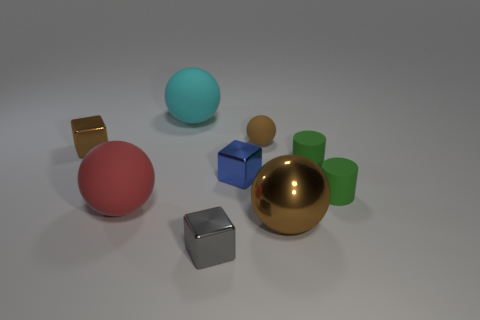What number of other things are the same shape as the small brown rubber thing?
Your answer should be very brief. 3. Is the gray cube the same size as the cyan rubber ball?
Keep it short and to the point. No. Is the number of big cyan matte objects that are on the left side of the tiny gray metallic object greater than the number of cyan things that are to the right of the small brown sphere?
Give a very brief answer. Yes. How many other things are there of the same size as the gray metallic object?
Give a very brief answer. 5. There is a small cube left of the cyan rubber ball; is its color the same as the small sphere?
Your response must be concise. Yes. Is the number of spheres that are on the left side of the brown metallic sphere greater than the number of tiny purple rubber cylinders?
Your answer should be very brief. Yes. Is there anything else that is the same color as the small sphere?
Offer a very short reply. Yes. The shiny thing that is on the left side of the big matte thing that is behind the brown cube is what shape?
Your answer should be very brief. Cube. Is the number of small green rubber cylinders greater than the number of brown things?
Make the answer very short. No. How many brown shiny things are both on the left side of the blue thing and on the right side of the red rubber sphere?
Your answer should be compact. 0. 